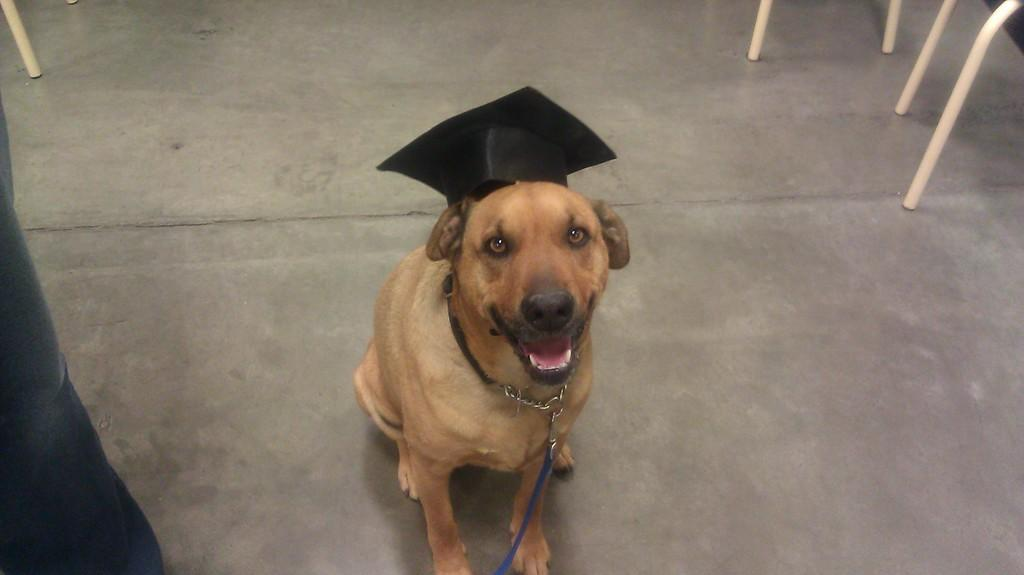What animal is present in the image? There is a dog in the image. What is the dog wearing on its head? The dog is wearing a black cap. Does the dog have any accessories? Yes, the dog has a belt. What can be seen on both sides of the dog? There are iron rods on the left side and the right side of the dog. How many feet does the dog have in the image? Dogs typically have four feet, but the image only shows the dog's upper body, so it's not possible to determine the exact number of feet visible. 